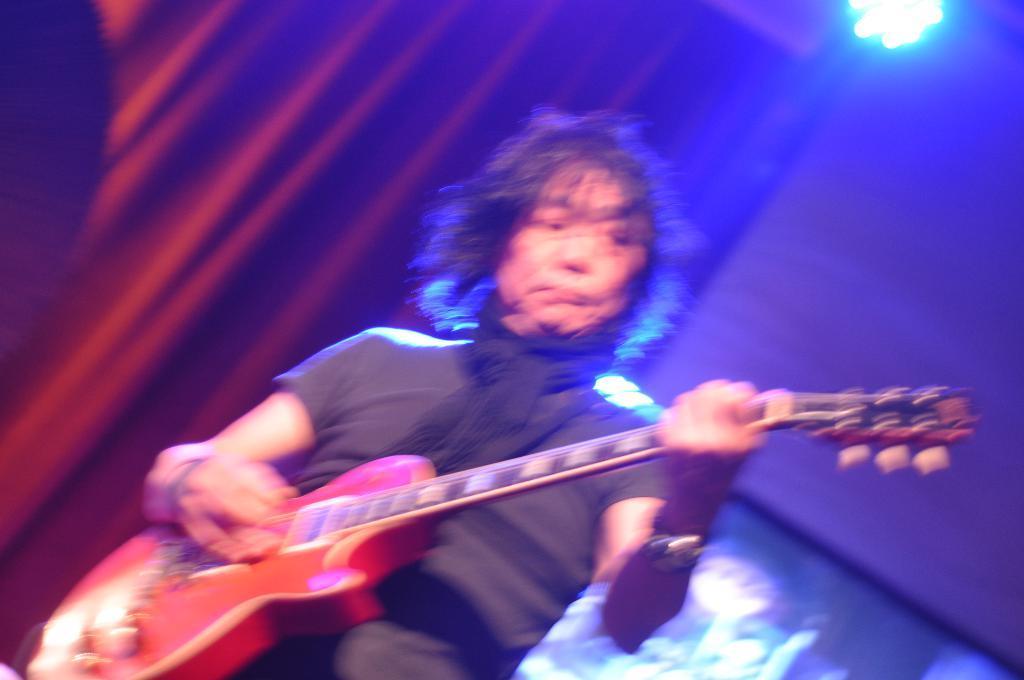Describe this image in one or two sentences. This man is playing a guitar and wore scarf. On top there is a light. This is red curtain. 